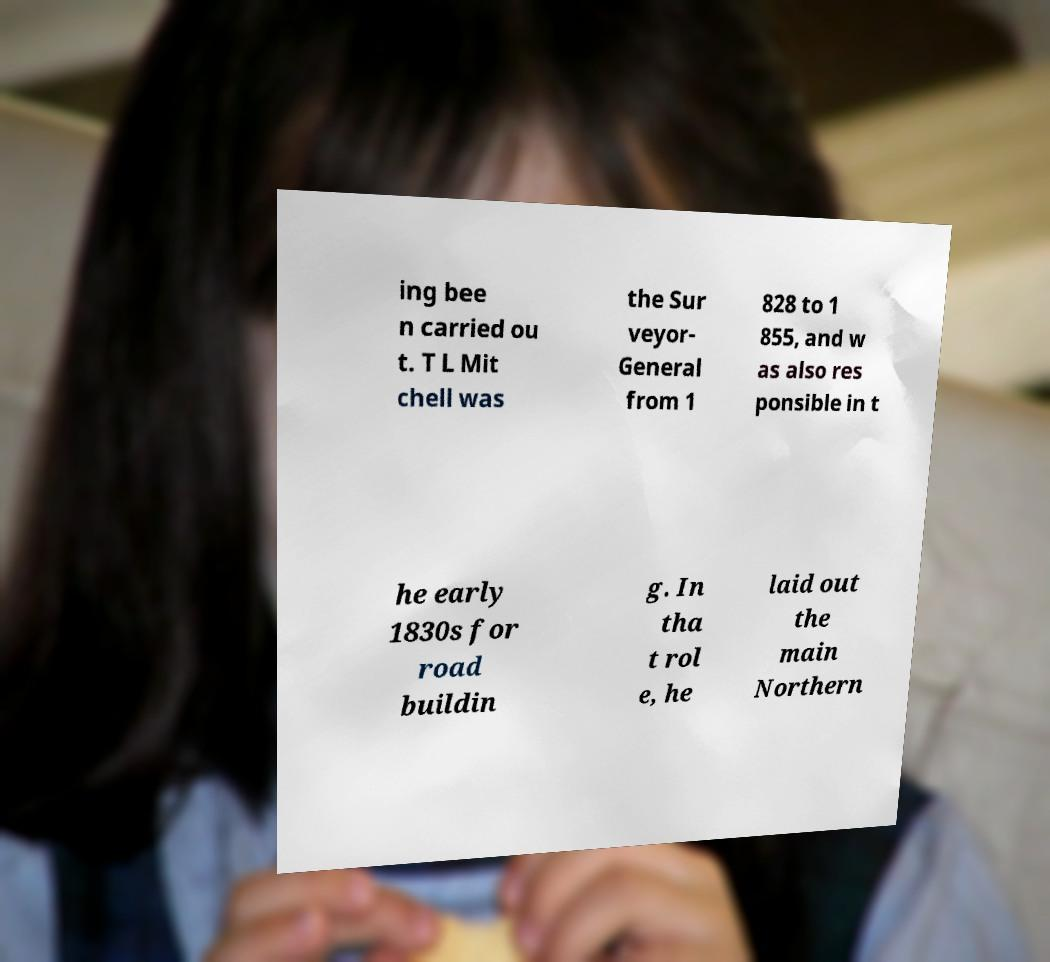Please identify and transcribe the text found in this image. ing bee n carried ou t. T L Mit chell was the Sur veyor- General from 1 828 to 1 855, and w as also res ponsible in t he early 1830s for road buildin g. In tha t rol e, he laid out the main Northern 